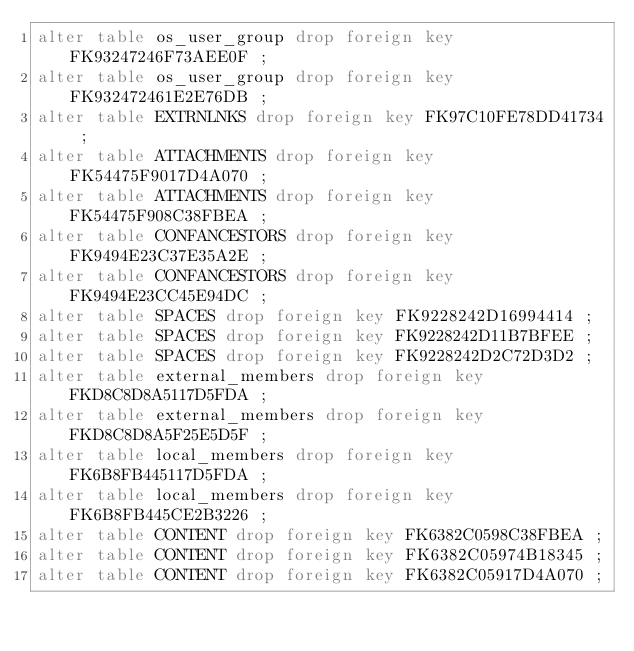<code> <loc_0><loc_0><loc_500><loc_500><_SQL_>alter table os_user_group drop foreign key FK93247246F73AEE0F ;
alter table os_user_group drop foreign key FK932472461E2E76DB ;
alter table EXTRNLNKS drop foreign key FK97C10FE78DD41734 ;
alter table ATTACHMENTS drop foreign key FK54475F9017D4A070 ;
alter table ATTACHMENTS drop foreign key FK54475F908C38FBEA ;
alter table CONFANCESTORS drop foreign key FK9494E23C37E35A2E ;
alter table CONFANCESTORS drop foreign key FK9494E23CC45E94DC ;
alter table SPACES drop foreign key FK9228242D16994414 ;
alter table SPACES drop foreign key FK9228242D11B7BFEE ;
alter table SPACES drop foreign key FK9228242D2C72D3D2 ;
alter table external_members drop foreign key FKD8C8D8A5117D5FDA ;
alter table external_members drop foreign key FKD8C8D8A5F25E5D5F ;
alter table local_members drop foreign key FK6B8FB445117D5FDA ;
alter table local_members drop foreign key FK6B8FB445CE2B3226 ;
alter table CONTENT drop foreign key FK6382C0598C38FBEA ;
alter table CONTENT drop foreign key FK6382C05974B18345 ;
alter table CONTENT drop foreign key FK6382C05917D4A070 ;</code> 